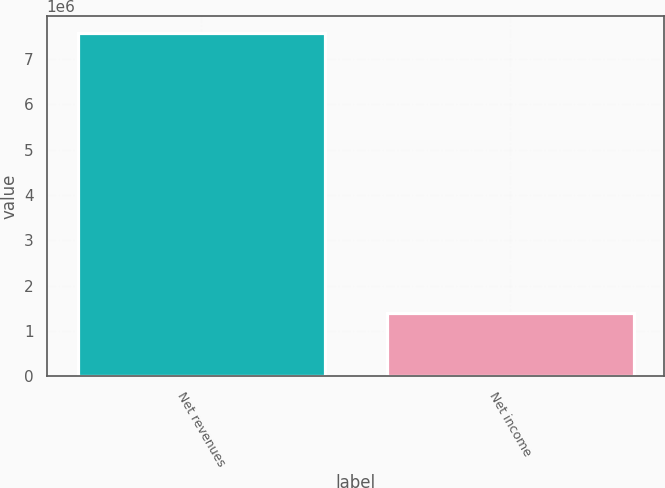Convert chart. <chart><loc_0><loc_0><loc_500><loc_500><bar_chart><fcel>Net revenues<fcel>Net income<nl><fcel>7.56871e+06<fcel>1.40486e+06<nl></chart> 